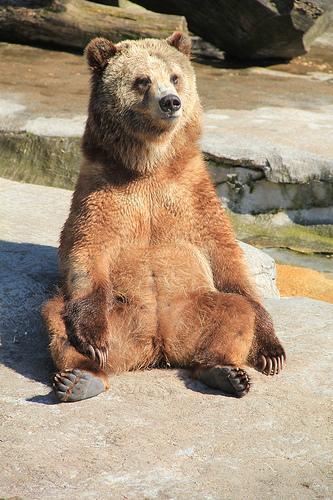How many bears are pictured?
Give a very brief answer. 1. 